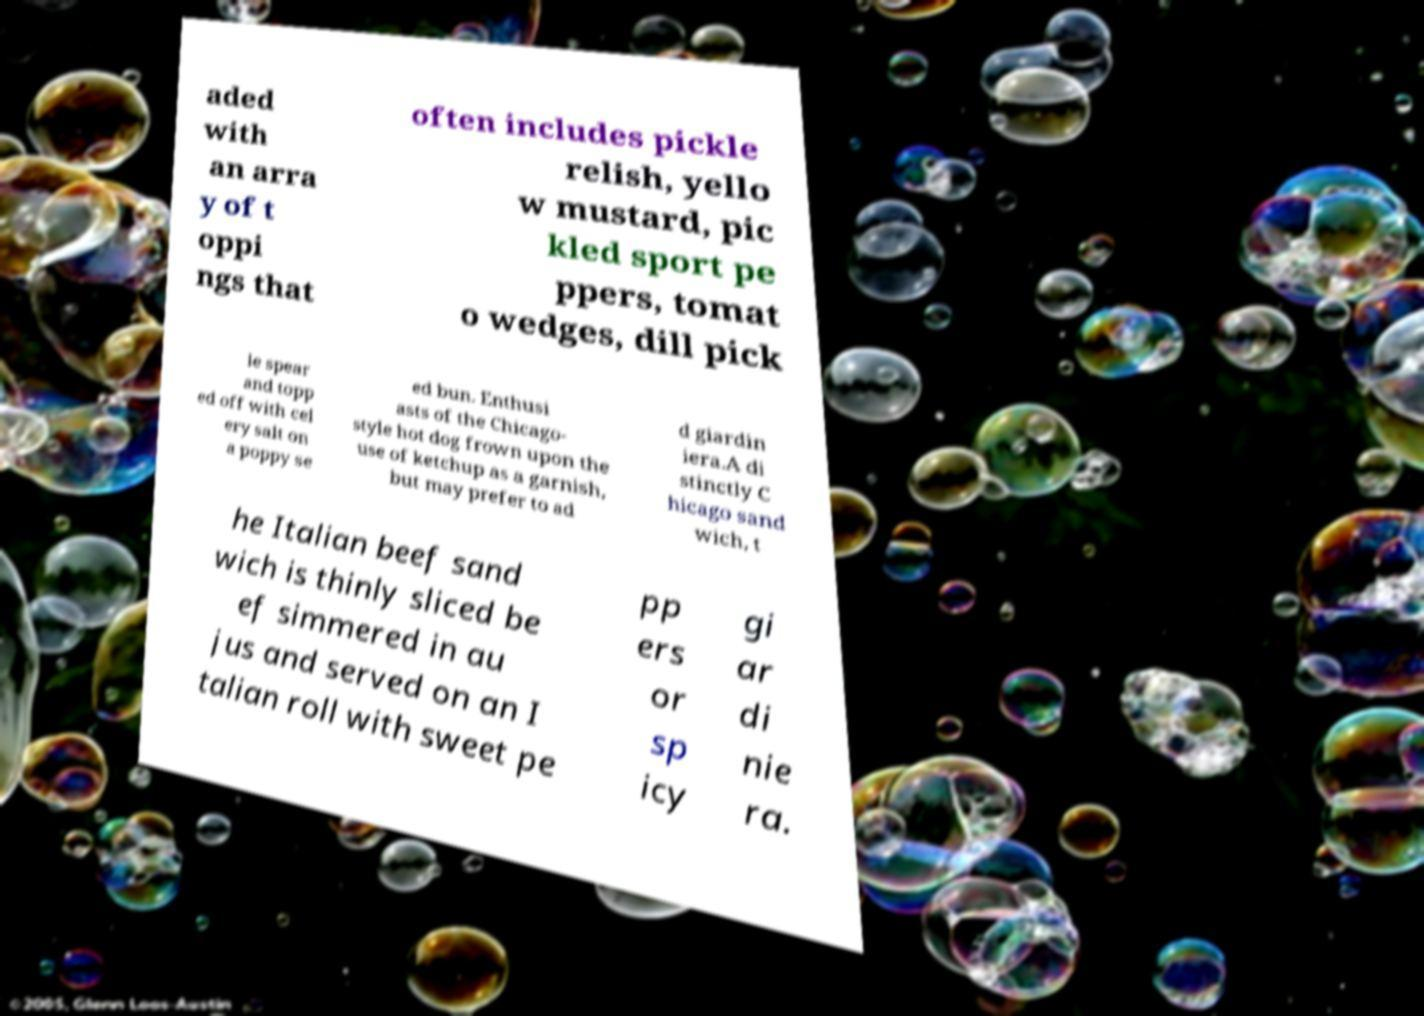There's text embedded in this image that I need extracted. Can you transcribe it verbatim? aded with an arra y of t oppi ngs that often includes pickle relish, yello w mustard, pic kled sport pe ppers, tomat o wedges, dill pick le spear and topp ed off with cel ery salt on a poppy se ed bun. Enthusi asts of the Chicago- style hot dog frown upon the use of ketchup as a garnish, but may prefer to ad d giardin iera.A di stinctly C hicago sand wich, t he Italian beef sand wich is thinly sliced be ef simmered in au jus and served on an I talian roll with sweet pe pp ers or sp icy gi ar di nie ra. 